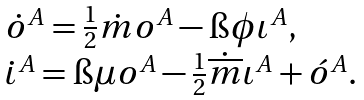Convert formula to latex. <formula><loc_0><loc_0><loc_500><loc_500>\begin{array} { l } \dot { o } ^ { A } = \frac { 1 } { 2 } \dot { m } o ^ { A } - \i \phi \iota ^ { A } , \\ \dot { \iota } ^ { A } = \i \mu o ^ { A } - \frac { 1 } { 2 } \dot { \overline { m } } \iota ^ { A } + \acute { o } ^ { A } . \end{array}</formula> 